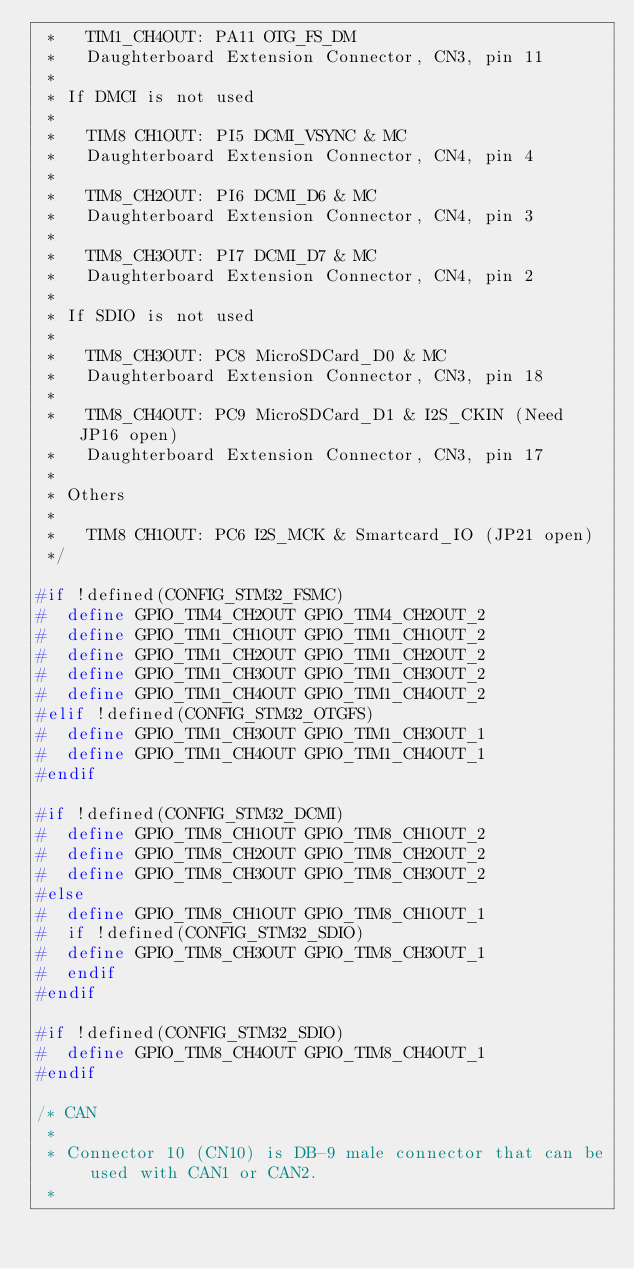Convert code to text. <code><loc_0><loc_0><loc_500><loc_500><_C_> *   TIM1_CH4OUT: PA11 OTG_FS_DM
 *   Daughterboard Extension Connector, CN3, pin 11
 *
 * If DMCI is not used
 *
 *   TIM8 CH1OUT: PI5 DCMI_VSYNC & MC
 *   Daughterboard Extension Connector, CN4, pin 4
 *
 *   TIM8_CH2OUT: PI6 DCMI_D6 & MC
 *   Daughterboard Extension Connector, CN4, pin 3
 *
 *   TIM8_CH3OUT: PI7 DCMI_D7 & MC
 *   Daughterboard Extension Connector, CN4, pin 2
 *
 * If SDIO is not used
 *
 *   TIM8_CH3OUT: PC8 MicroSDCard_D0 & MC
 *   Daughterboard Extension Connector, CN3, pin 18
 *
 *   TIM8_CH4OUT: PC9 MicroSDCard_D1 & I2S_CKIN (Need JP16 open)
 *   Daughterboard Extension Connector, CN3, pin 17
 *
 * Others
 *
 *   TIM8 CH1OUT: PC6 I2S_MCK & Smartcard_IO (JP21 open)
 */

#if !defined(CONFIG_STM32_FSMC)
#  define GPIO_TIM4_CH2OUT GPIO_TIM4_CH2OUT_2
#  define GPIO_TIM1_CH1OUT GPIO_TIM1_CH1OUT_2
#  define GPIO_TIM1_CH2OUT GPIO_TIM1_CH2OUT_2
#  define GPIO_TIM1_CH3OUT GPIO_TIM1_CH3OUT_2
#  define GPIO_TIM1_CH4OUT GPIO_TIM1_CH4OUT_2
#elif !defined(CONFIG_STM32_OTGFS)
#  define GPIO_TIM1_CH3OUT GPIO_TIM1_CH3OUT_1
#  define GPIO_TIM1_CH4OUT GPIO_TIM1_CH4OUT_1
#endif

#if !defined(CONFIG_STM32_DCMI)
#  define GPIO_TIM8_CH1OUT GPIO_TIM8_CH1OUT_2
#  define GPIO_TIM8_CH2OUT GPIO_TIM8_CH2OUT_2
#  define GPIO_TIM8_CH3OUT GPIO_TIM8_CH3OUT_2
#else
#  define GPIO_TIM8_CH1OUT GPIO_TIM8_CH1OUT_1
#  if !defined(CONFIG_STM32_SDIO)
#  define GPIO_TIM8_CH3OUT GPIO_TIM8_CH3OUT_1
#  endif
#endif

#if !defined(CONFIG_STM32_SDIO)
#  define GPIO_TIM8_CH4OUT GPIO_TIM8_CH4OUT_1
#endif

/* CAN
 *
 * Connector 10 (CN10) is DB-9 male connector that can be used with CAN1 or CAN2.
 *</code> 